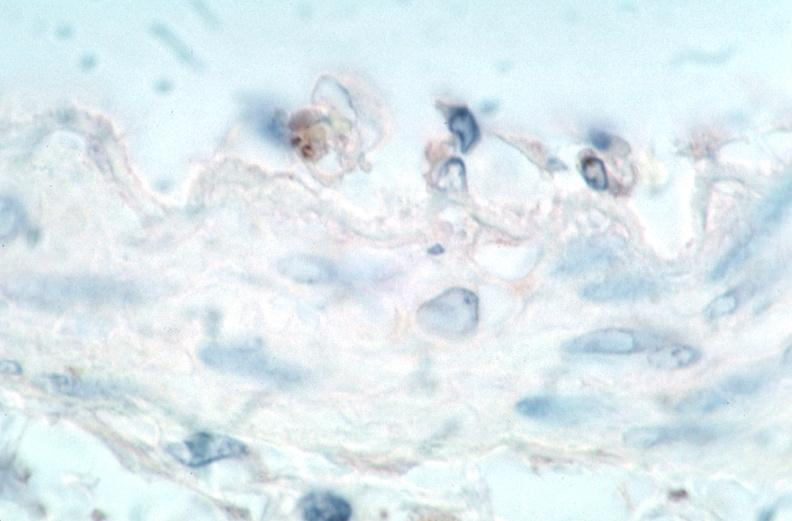what spotted fever, immunoperoxidase staining vessels for rickettsia rickettsii?
Answer the question using a single word or phrase. Rocky mountain 